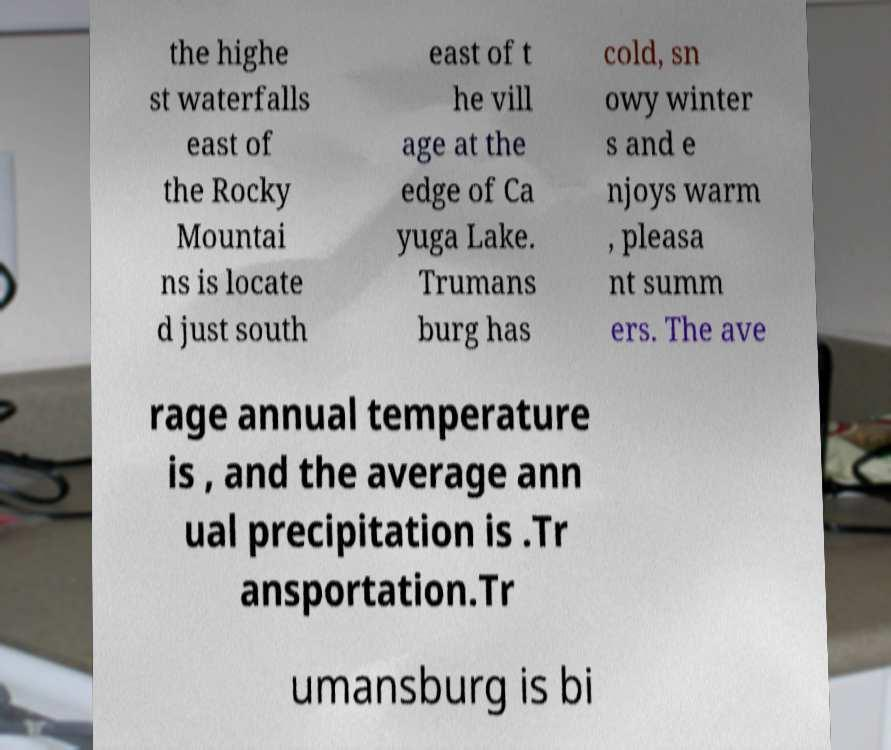Please read and relay the text visible in this image. What does it say? the highe st waterfalls east of the Rocky Mountai ns is locate d just south east of t he vill age at the edge of Ca yuga Lake. Trumans burg has cold, sn owy winter s and e njoys warm , pleasa nt summ ers. The ave rage annual temperature is , and the average ann ual precipitation is .Tr ansportation.Tr umansburg is bi 